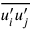Convert formula to latex. <formula><loc_0><loc_0><loc_500><loc_500>\overline { { { u _ { i } ^ { \prime } } u _ { j } ^ { \prime } } }</formula> 